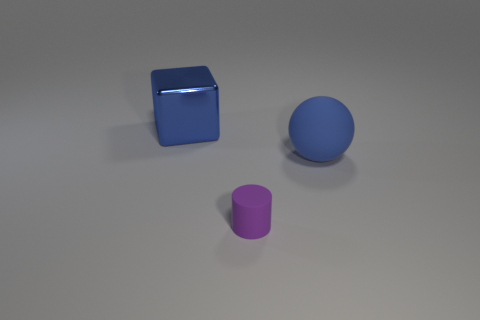Add 1 small yellow metallic cylinders. How many objects exist? 4 Subtract all balls. How many objects are left? 2 Add 3 large green metallic balls. How many large green metallic balls exist? 3 Subtract 0 green cylinders. How many objects are left? 3 Subtract all brown cubes. Subtract all red spheres. How many cubes are left? 1 Subtract all small purple blocks. Subtract all large blue metal blocks. How many objects are left? 2 Add 3 purple cylinders. How many purple cylinders are left? 4 